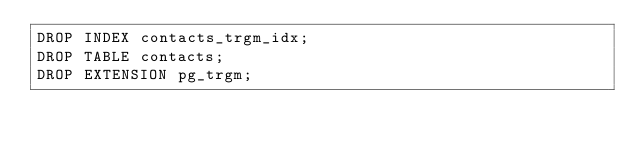<code> <loc_0><loc_0><loc_500><loc_500><_SQL_>DROP INDEX contacts_trgm_idx;
DROP TABLE contacts;
DROP EXTENSION pg_trgm;
</code> 